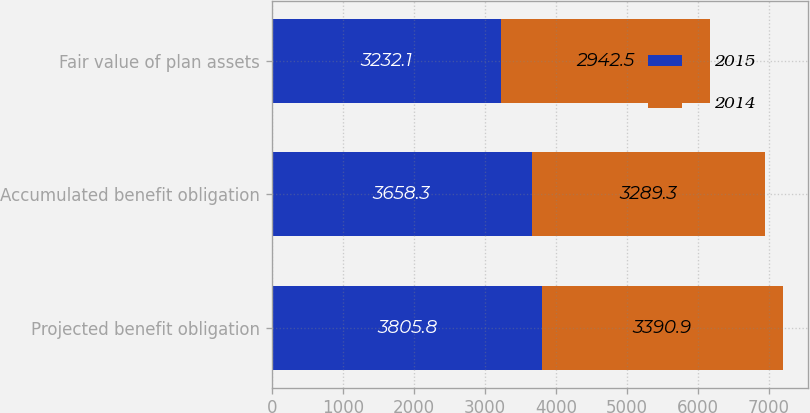<chart> <loc_0><loc_0><loc_500><loc_500><stacked_bar_chart><ecel><fcel>Projected benefit obligation<fcel>Accumulated benefit obligation<fcel>Fair value of plan assets<nl><fcel>2015<fcel>3805.8<fcel>3658.3<fcel>3232.1<nl><fcel>2014<fcel>3390.9<fcel>3289.3<fcel>2942.5<nl></chart> 